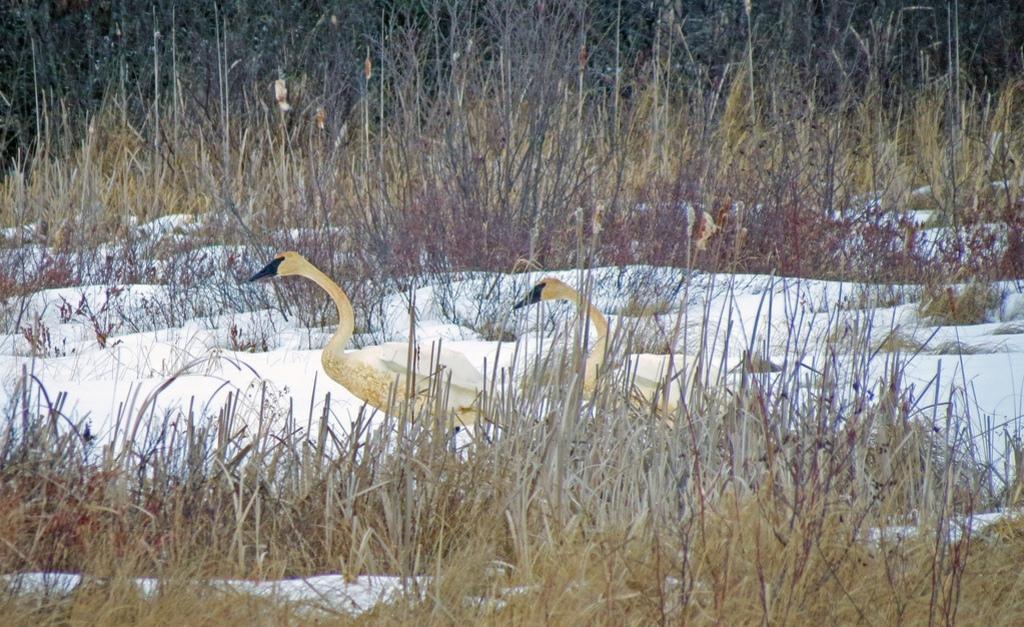Can you describe this image briefly? In this picture I can observe two birds on the land. There is some grass and snow on the land. In the background there are trees. 